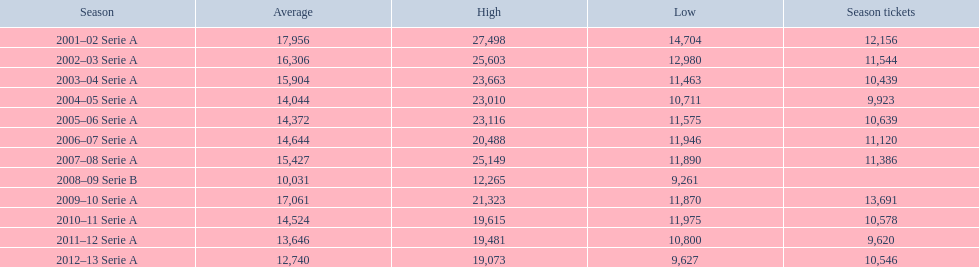What are the various seasons? 2001–02 Serie A, 2002–03 Serie A, 2003–04 Serie A, 2004–05 Serie A, 2005–06 Serie A, 2006–07 Serie A, 2007–08 Serie A, 2008–09 Serie B, 2009–10 Serie A, 2010–11 Serie A, 2011–12 Serie A, 2012–13 Serie A. Which specific season occurred in 2007? 2007–08 Serie A. How many season passes were purchased during that season? 11,386. 